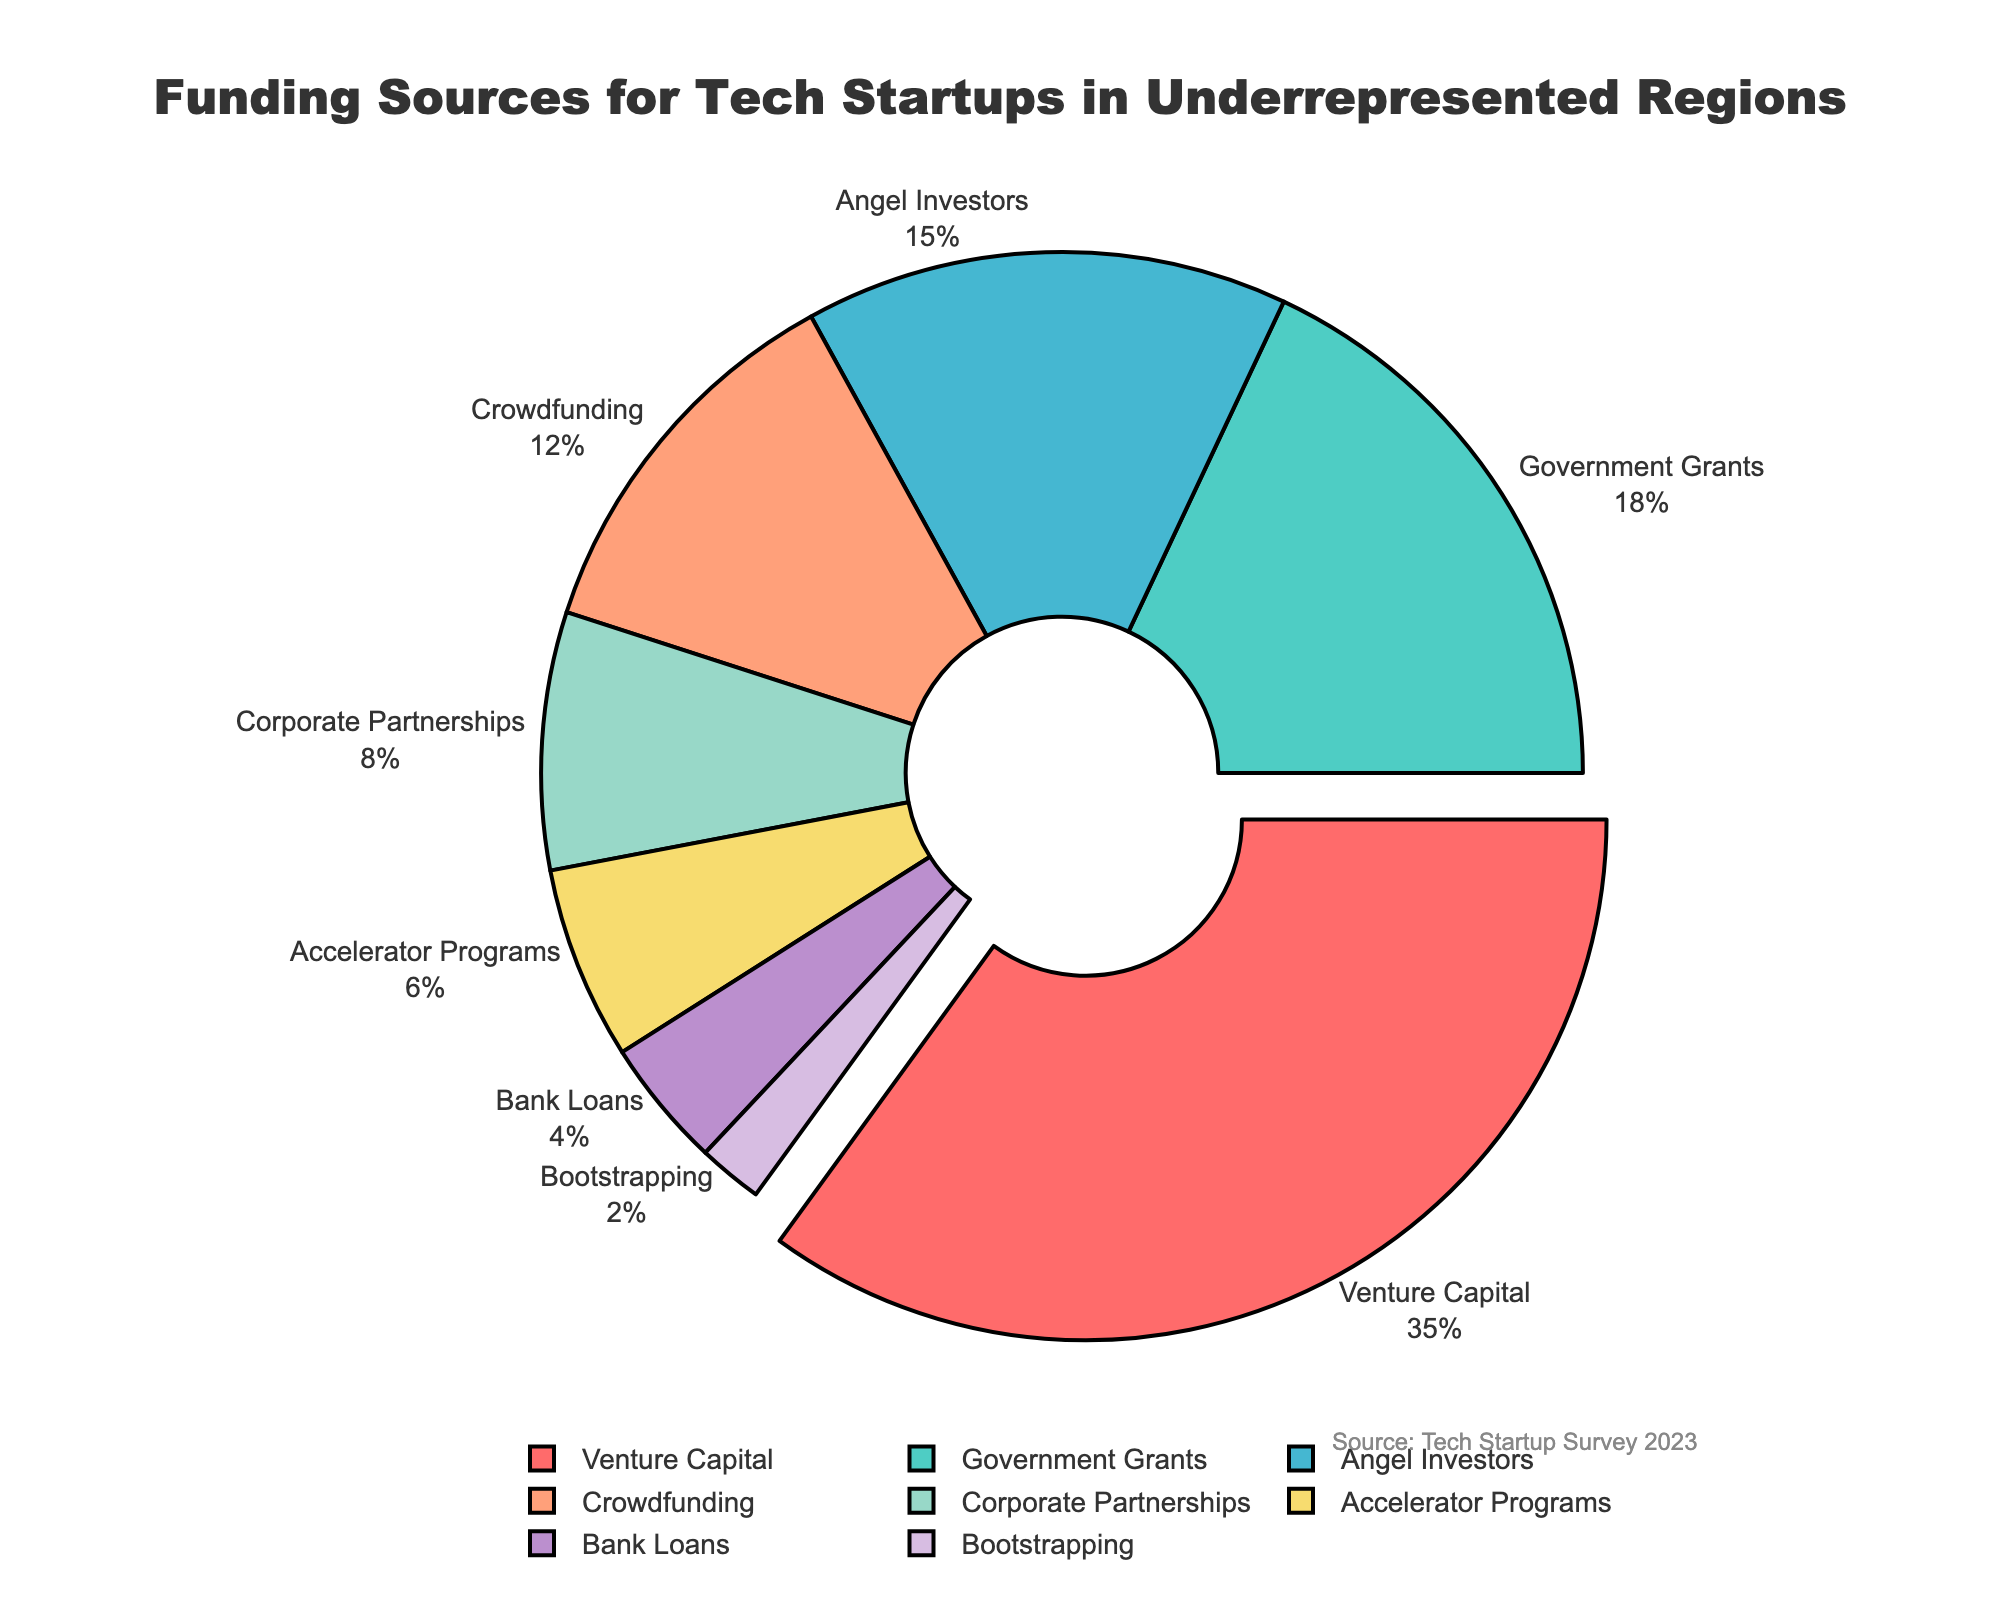What is the largest funding source for tech startups in underrepresented regions? Look at the pie chart and observe that the largest section is labeled "Venture Capital" with a percentage of 35%.
Answer: Venture Capital What are the combined percentages of funding from Angel Investors and Crowdfunding? Add the percentages of Angel Investors (15%) and Crowdfunding (12%): 15 + 12 = 27%.
Answer: 27% Which funding source has the smallest percentage, and what is it? Identify the smallest section of the pie chart, which is labeled "Bootstrapping" and shows a percentage of 2%.
Answer: Bootstrapping, 2% How much greater is the percentage of Government Grants compared to Bank Loans? Subtract the percentage of Bank Loans (4%) from Government Grants (18%): 18 - 4 = 14%.
Answer: 14% What is the total percentage of funding covered by Corporate Partnerships and Accelerator Programs? Add the percentages of Corporate Partnerships (8%) and Accelerator Programs (6%): 8 + 6 = 14%.
Answer: 14% Which source is highlighted or pulled out from the pie chart, and why might it be the case? The section labeled "Venture Capital" is slightly pulled out, indicating it has the highest percentage at 35%.
Answer: Venture Capital, 35% What is the difference in funding between the highest (Venture Capital) and the second-highest (Government Grants) sources? Subtract the percentage of Government Grants (18%) from Venture Capital (35%): 35 - 18 = 17%.
Answer: 17% Describe the visual appearance of the section representing Crowdfunding in terms of its color and position. The section labeled "Crowdfunding" is colored pink and is positioned on the right side of the pie chart.
Answer: Pink, right side How does the percentage of Accelerator Programs compare to that of Bank Loans? Compare the percentages: Accelerator Programs (6%) are greater than Bank Loans (4%).
Answer: Greater What is the combined percentage of sources that individually contribute less than 10%? Add the percentages of sources that each contribute less than 10%: Corporate Partnerships (8%), Accelerator Programs (6%), Bank Loans (4%), and Bootstrapping (2%): 8 + 6 + 4 + 2 = 20%.
Answer: 20% 